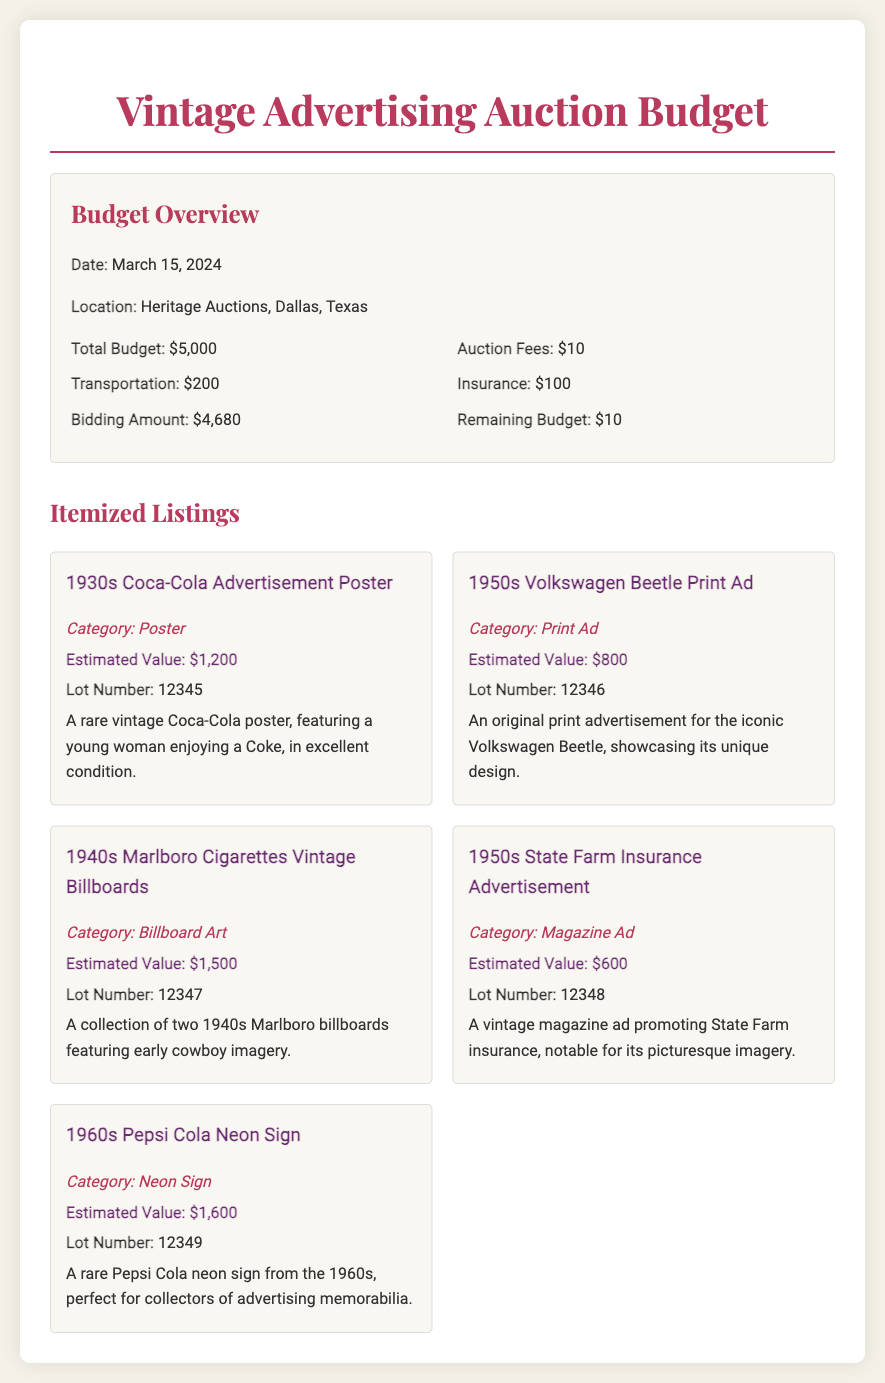What is the total budget? The total budget is stated clearly in the budget overview section as $5,000.
Answer: $5,000 When is the auction date? The auction date is specifically mentioned in the budget overview as March 15, 2024.
Answer: March 15, 2024 What is the estimated value of the 1960s Pepsi Cola Neon Sign? The estimated value for the neon sign is provided as $1,600 in the itemized listings.
Answer: $1,600 How much is allocated for insurance? The amount allocated for insurance is detailed in the budget overview as $100.
Answer: $100 What category does the 1930s Coca-Cola Advertisement belong to? The category of the advertisement is mentioned in the item details as "Poster."
Answer: Poster What is the remaining budget after accounting for auction fees and costs? The remaining budget is calculated based on the total budget minus expenses, given as $10 in the budget overview.
Answer: $10 Which item has the highest estimated value? By comparing the values listed, the item with the highest estimated value is the 1940s Marlboro Cigarettes Vintage Billboards at $1,500.
Answer: $1,500 What is the lot number for the 1950s Volkswagen Beetle Print Ad? The lot number for the print ad is provided in its description as 12346.
Answer: 12346 How much is set aside for transportation? The budget overview specifies that $200 is designated for transportation costs.
Answer: $200 